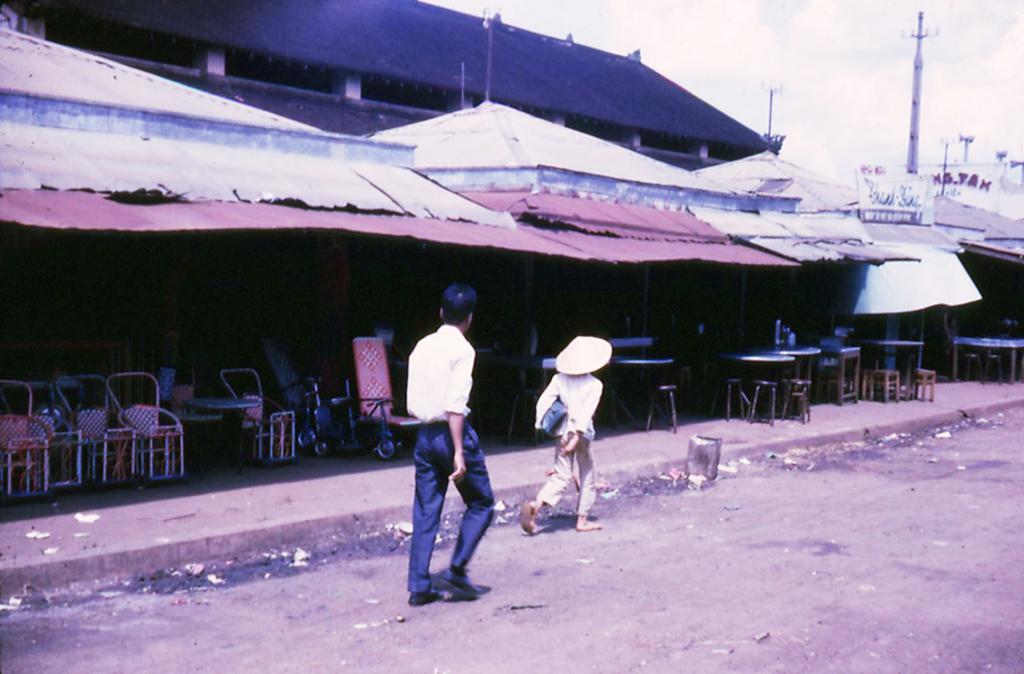Can you describe this image briefly? In this picture there is a man wearing white color shirt and black pant is walking on the road. In the front there is a woman wearing cowboy cap and holding the bag in the hand is walking. Behind there is a tables and chairs. In the background there is a warehouse with shed roof and some electric poles. 